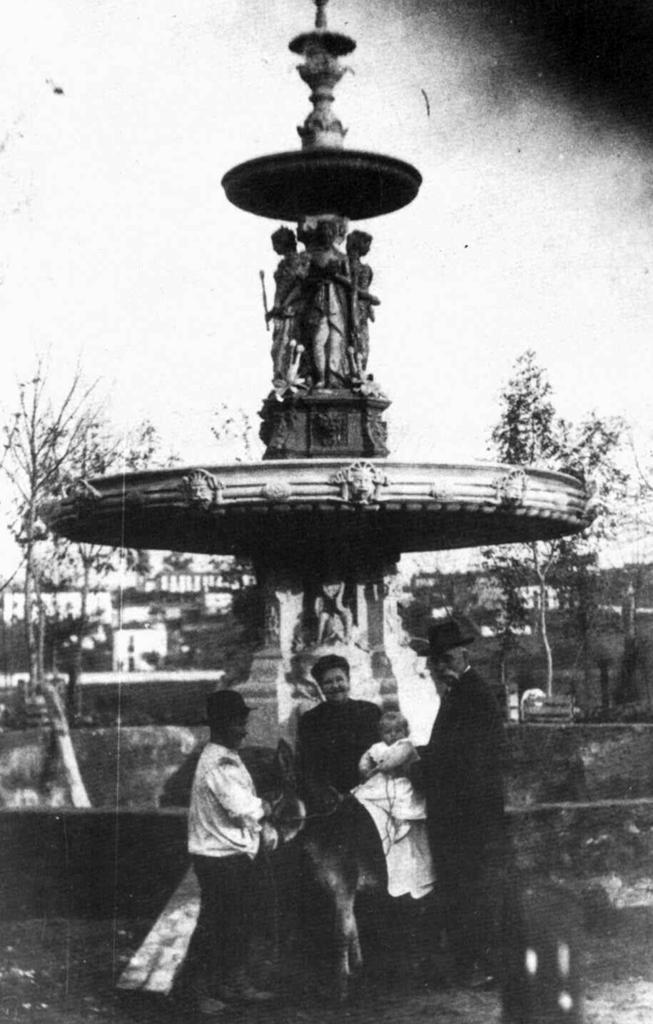In one or two sentences, can you explain what this image depicts? This is a black and white picture. Here we can see few persons, statues, trees, and buildings. In the background there is sky. 